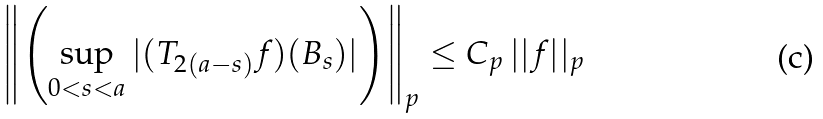<formula> <loc_0><loc_0><loc_500><loc_500>\left \| \left ( \sup _ { 0 < s < a } | ( T _ { 2 ( a - s ) } f ) ( B _ { s } ) | \right ) \right \| _ { p } \leq C _ { p } \, | | f | | _ { p }</formula> 